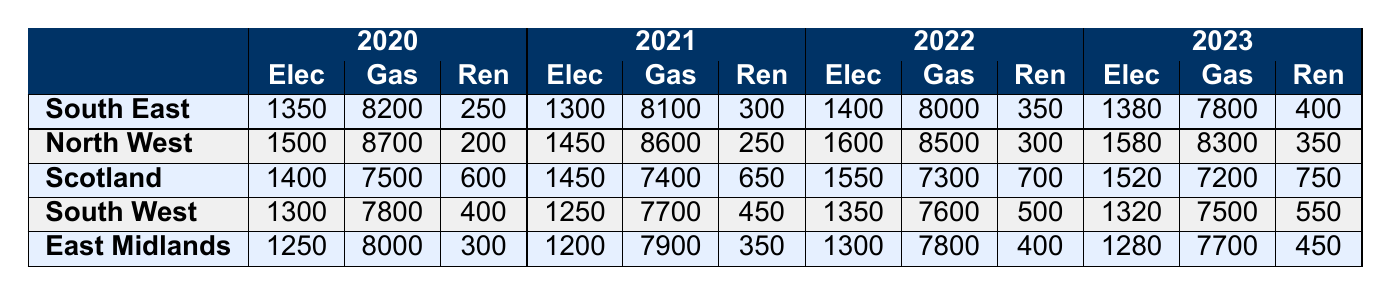What was the total electricity consumption in South East for 2022? In 2022, the electricity consumption in the South East is 1400 kWh.
Answer: 1400 kWh Which region had the highest gas consumption in 2020? In 2020, the North West had the highest gas consumption of 8700 kWh.
Answer: North West What is the overall change in renewable energy consumption in the South West from 2020 to 2023? In the South West, renewable energy consumption increased from 400 kWh in 2020 to 550 kWh in 2023, resulting in an increase of 150 kWh.
Answer: 150 kWh Did Scotland reduce its gas consumption from 2020 to 2023? Yes, Scotland reduced its gas consumption from 7500 kWh in 2020 to 7200 kWh in 2023.
Answer: Yes What is the average electricity consumption across all regions in 2021? The total electricity consumption in 2021 for all regions is calculated as follows: South East (1300) + North West (1450) + Scotland (1450) + South West (1250) + East Midlands (1200) = 6700 kWh. Dividing by 5 regions gives us an average of 1340 kWh.
Answer: 1340 kWh Which region had the largest increase in renewable energy consumption from 2020 to 2023? For the periods given, Scotland had an increase from 600 kWh in 2020 to 750 kWh in 2023, making an increase of 150 kWh, which was the largest increase among all regions.
Answer: Scotland What was the electricity consumption in the East Midlands in 2023? In 2023, the electricity consumption in the East Midlands was 1280 kWh.
Answer: 1280 kWh Is the total gas consumption in 2022 for the South West lower than that in 2020? Yes, the gas consumption in the South West was 7600 kWh in 2022, which is lower than the 7800 kWh recorded in 2020.
Answer: Yes 